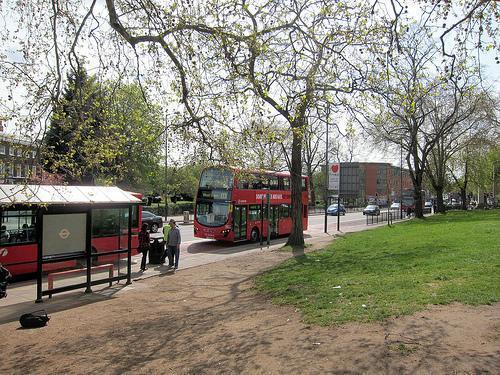How many of the buses visible on the street are two story?
Give a very brief answer. 2. 